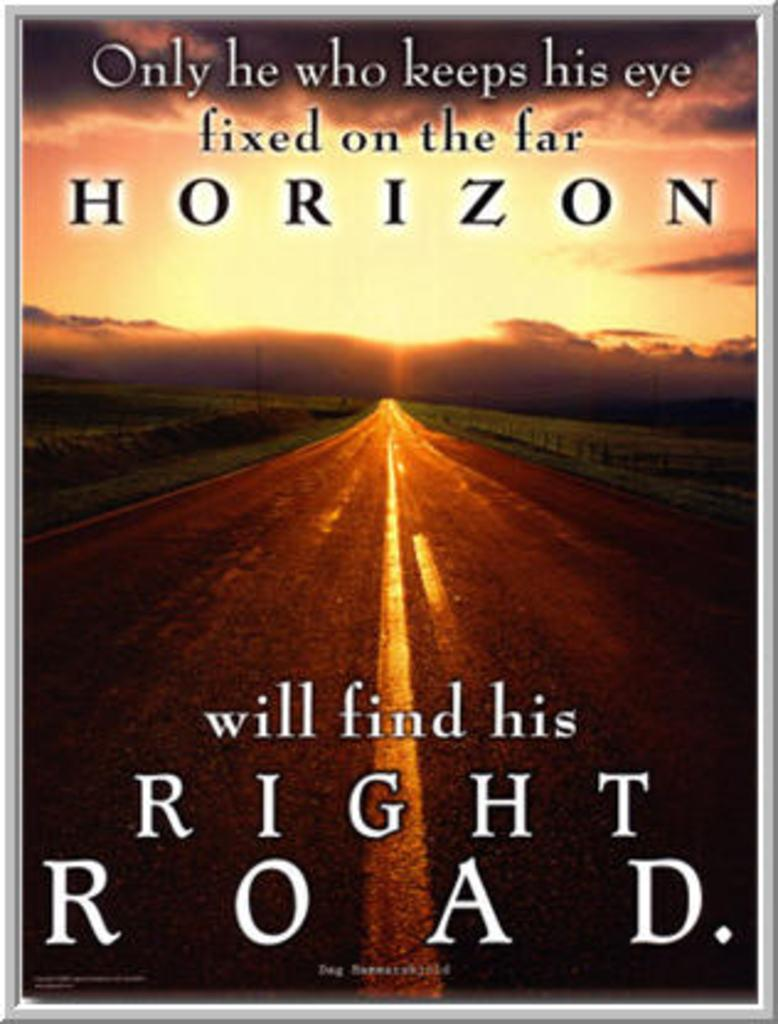<image>
Create a compact narrative representing the image presented. Cover that says "Only he who keeps his eye" showing an empty road. 